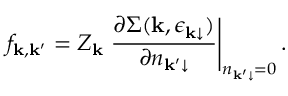<formula> <loc_0><loc_0><loc_500><loc_500>f _ { \mathbf k , \mathbf k ^ { \prime } } = Z _ { \mathbf k } \frac { \partial \Sigma ( \mathbf k , { \epsilon _ { \mathbf k \downarrow } } ) } { \partial n _ { \mathbf k ^ { \prime } \downarrow } } \right | _ { n _ { \mathbf k ^ { \prime } \downarrow } = 0 } .</formula> 